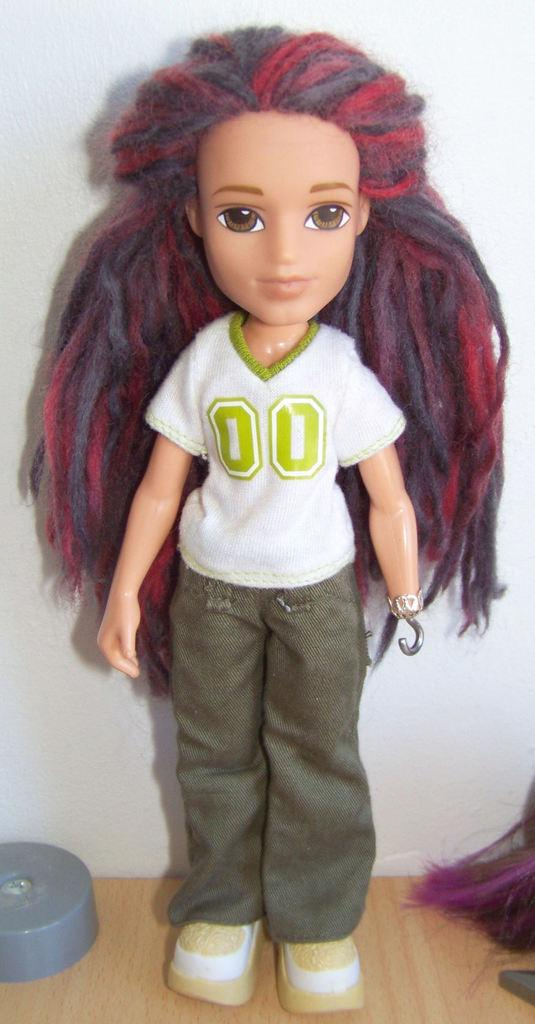What is placed on the table in the image? There is a doll placed on the table. Can you describe the doll's position or orientation on the table? The provided facts do not specify the doll's position or orientation on the table. What might be the purpose of placing the doll on the table? The purpose of placing the doll on the table is not mentioned in the provided facts. What is the taste of the doll in the image? Dolls do not have a taste, as they are inanimate objects made of materials like plastic or fabric. 